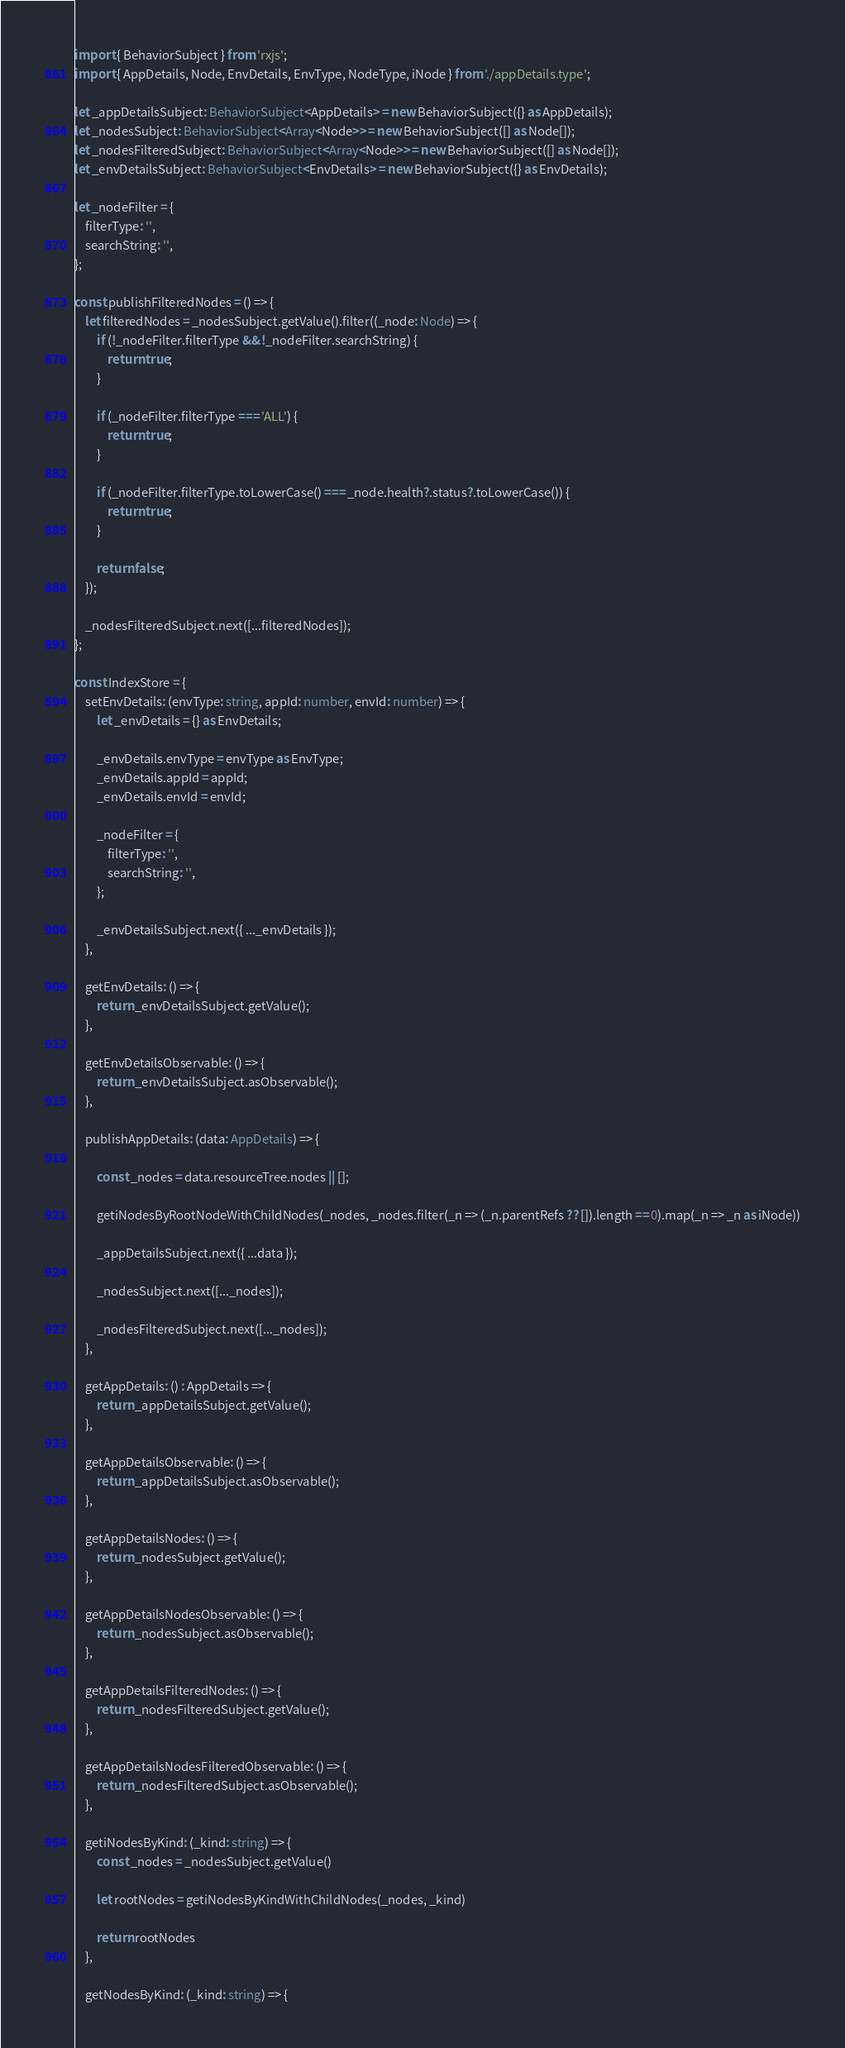Convert code to text. <code><loc_0><loc_0><loc_500><loc_500><_TypeScript_>import { BehaviorSubject } from 'rxjs';
import { AppDetails, Node, EnvDetails, EnvType, NodeType, iNode } from './appDetails.type';

let _appDetailsSubject: BehaviorSubject<AppDetails> = new BehaviorSubject({} as AppDetails);
let _nodesSubject: BehaviorSubject<Array<Node>> = new BehaviorSubject([] as Node[]);
let _nodesFilteredSubject: BehaviorSubject<Array<Node>> = new BehaviorSubject([] as Node[]);
let _envDetailsSubject: BehaviorSubject<EnvDetails> = new BehaviorSubject({} as EnvDetails);

let _nodeFilter = {
    filterType: '',
    searchString: '',
};

const publishFilteredNodes = () => {
    let filteredNodes = _nodesSubject.getValue().filter((_node: Node) => {
        if (!_nodeFilter.filterType && !_nodeFilter.searchString) {
            return true;
        }

        if (_nodeFilter.filterType === 'ALL') {
            return true;
        }

        if (_nodeFilter.filterType.toLowerCase() === _node.health?.status?.toLowerCase()) {
            return true;
        }

        return false;
    });

    _nodesFilteredSubject.next([...filteredNodes]);
};

const IndexStore = {
    setEnvDetails: (envType: string, appId: number, envId: number) => {
        let _envDetails = {} as EnvDetails;

        _envDetails.envType = envType as EnvType;
        _envDetails.appId = appId;
        _envDetails.envId = envId;

        _nodeFilter = {
            filterType: '',
            searchString: '',
        };

        _envDetailsSubject.next({ ..._envDetails });
    },

    getEnvDetails: () => {
        return _envDetailsSubject.getValue();
    },

    getEnvDetailsObservable: () => {
        return _envDetailsSubject.asObservable();
    },

    publishAppDetails: (data: AppDetails) => {

        const _nodes = data.resourceTree.nodes || [];

        getiNodesByRootNodeWithChildNodes(_nodes, _nodes.filter(_n => (_n.parentRefs ?? []).length == 0).map(_n => _n as iNode))

        _appDetailsSubject.next({ ...data });

        _nodesSubject.next([..._nodes]);

        _nodesFilteredSubject.next([..._nodes]);
    },

    getAppDetails: () : AppDetails => {
        return _appDetailsSubject.getValue();
    },

    getAppDetailsObservable: () => {
        return _appDetailsSubject.asObservable();
    },

    getAppDetailsNodes: () => {
        return _nodesSubject.getValue();
    },

    getAppDetailsNodesObservable: () => {
        return _nodesSubject.asObservable();
    },

    getAppDetailsFilteredNodes: () => {
        return _nodesFilteredSubject.getValue();
    },

    getAppDetailsNodesFilteredObservable: () => {
        return _nodesFilteredSubject.asObservable();
    },

    getiNodesByKind: (_kind: string) => {
        const _nodes = _nodesSubject.getValue()

        let rootNodes = getiNodesByKindWithChildNodes(_nodes, _kind)

        return rootNodes
    },

    getNodesByKind: (_kind: string) => {</code> 